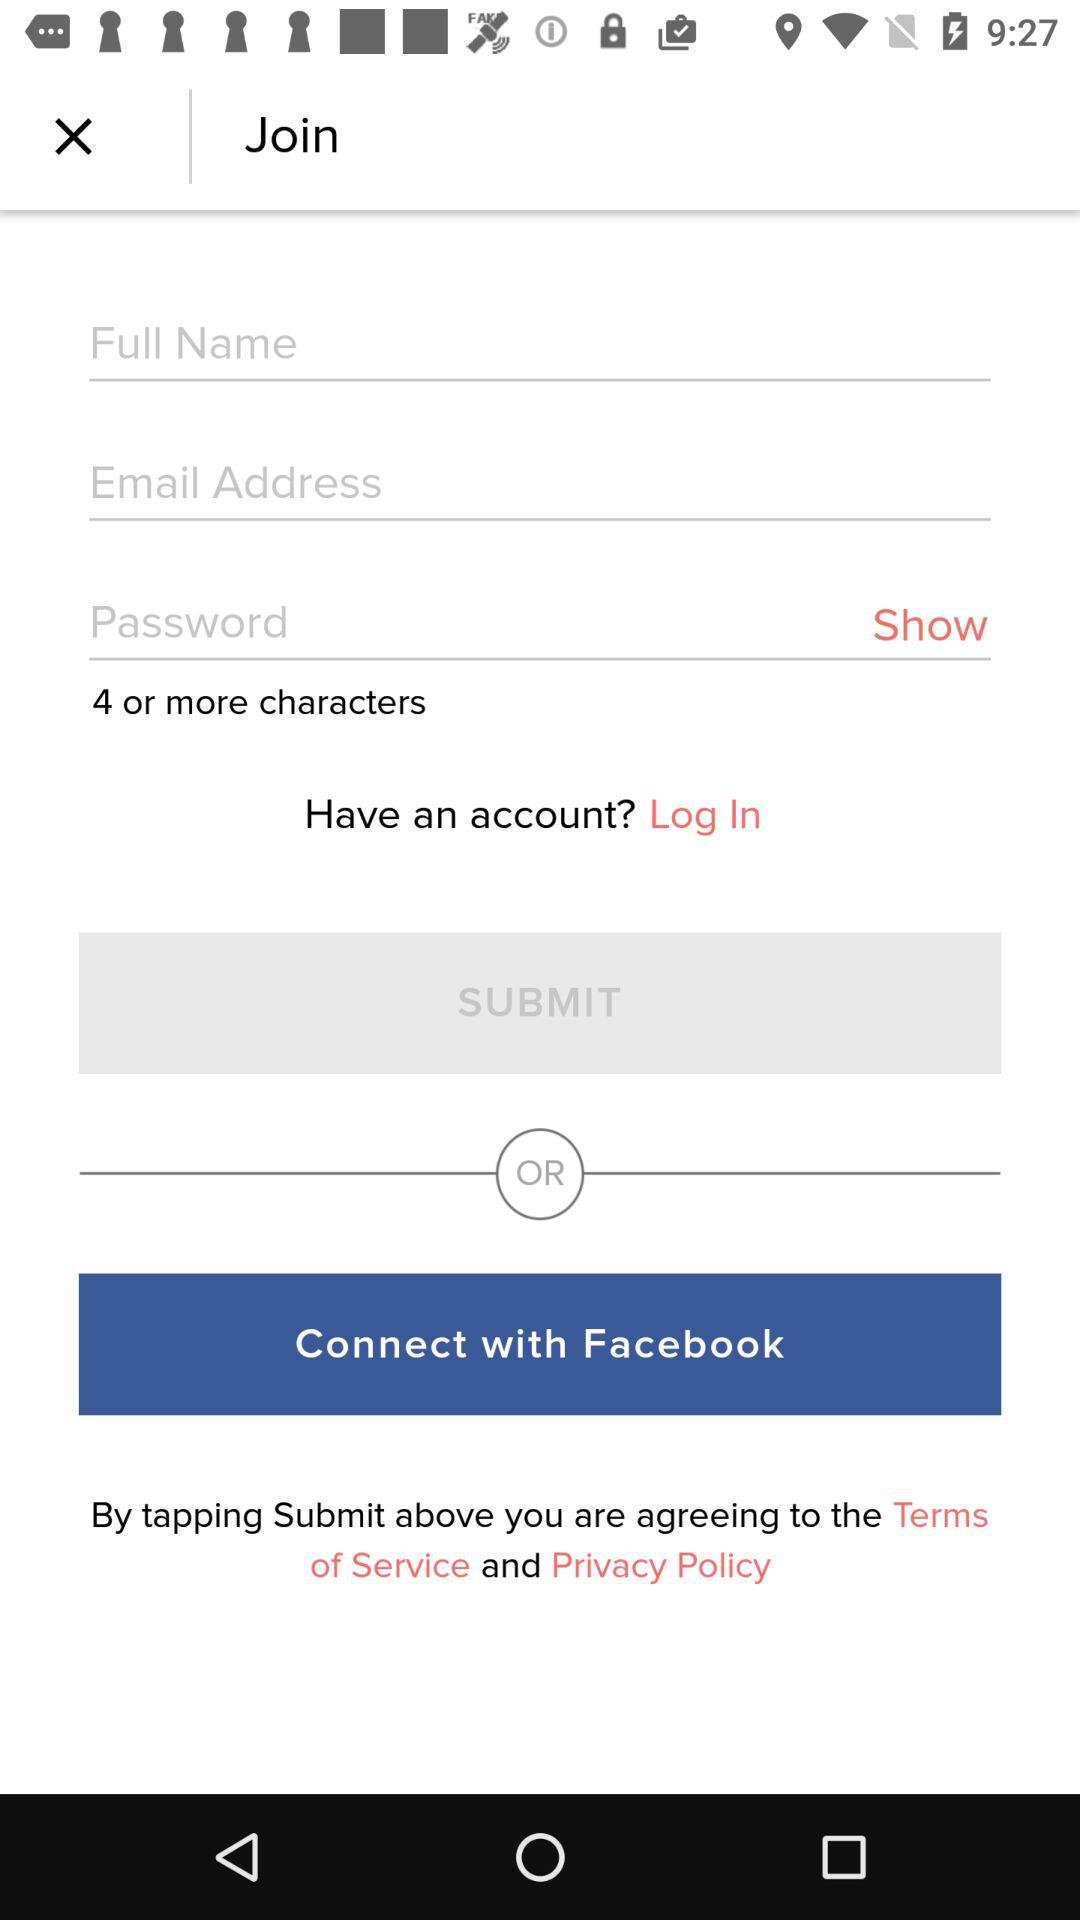Which is the different option to sign in?
When the provided information is insufficient, respond with <no answer>. <no answer> 